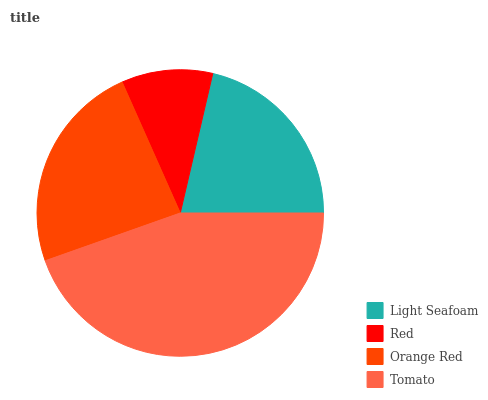Is Red the minimum?
Answer yes or no. Yes. Is Tomato the maximum?
Answer yes or no. Yes. Is Orange Red the minimum?
Answer yes or no. No. Is Orange Red the maximum?
Answer yes or no. No. Is Orange Red greater than Red?
Answer yes or no. Yes. Is Red less than Orange Red?
Answer yes or no. Yes. Is Red greater than Orange Red?
Answer yes or no. No. Is Orange Red less than Red?
Answer yes or no. No. Is Orange Red the high median?
Answer yes or no. Yes. Is Light Seafoam the low median?
Answer yes or no. Yes. Is Red the high median?
Answer yes or no. No. Is Tomato the low median?
Answer yes or no. No. 